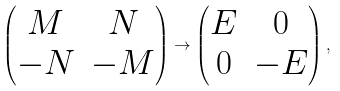<formula> <loc_0><loc_0><loc_500><loc_500>\begin{pmatrix} M & N \\ - N & - M \end{pmatrix} \to \begin{pmatrix} E & 0 \\ 0 & - E \end{pmatrix} ,</formula> 